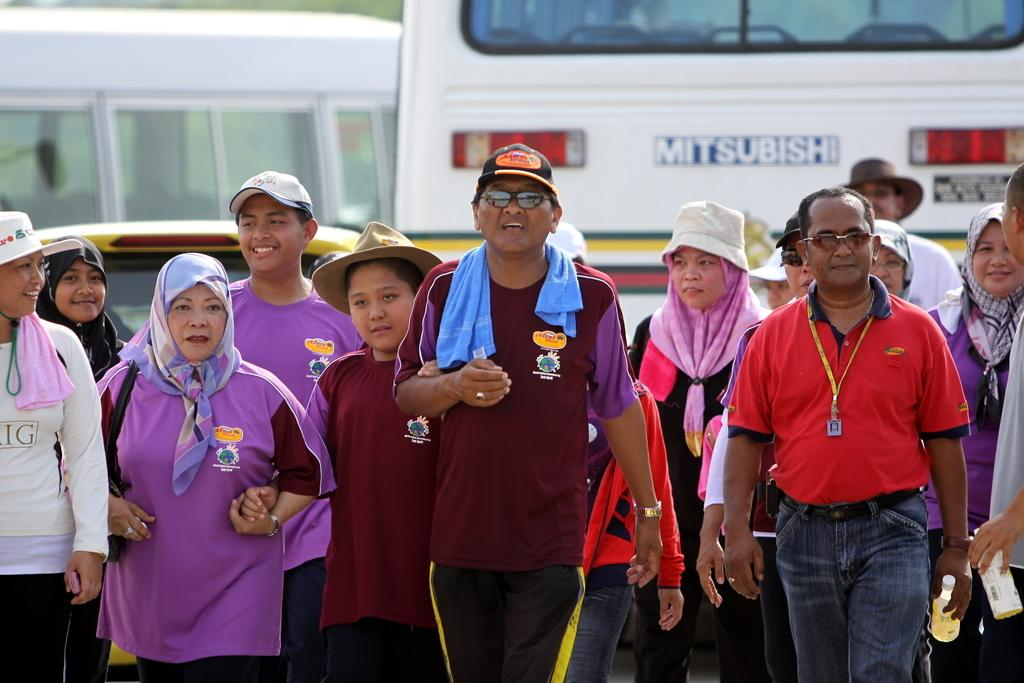What can be seen in the image? There is a group of people in the image. What are the people wearing? The people are wearing hats and scarves. What is visible in the background of the image? There are vehicles in the background of the image. What type of ice can be seen melting on the ground in the image? There is no ice present in the image; it features a group of people wearing hats and scarves, with vehicles in the background. 